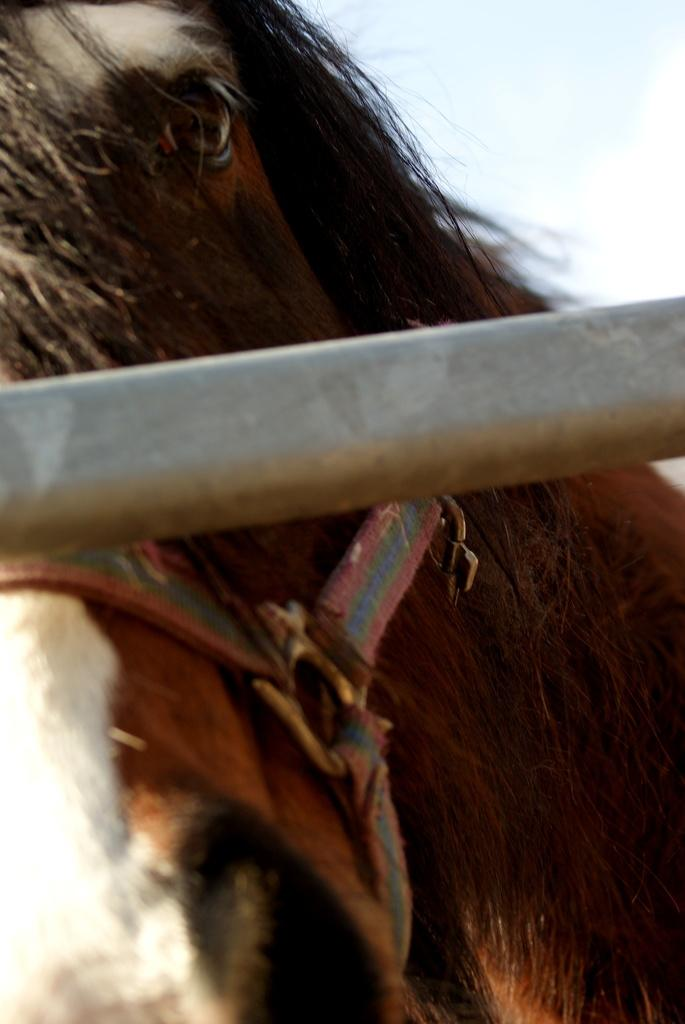What is the main object in the image? There is a pole in the image. What is the horse doing in the image? The horse has a belt tied to its head. What can be seen in the background of the image? The sky is visible in the background of the image. Who is the stranger wearing a shirt in the hall in the image? There is no stranger, shirt, or hall present in the image. 